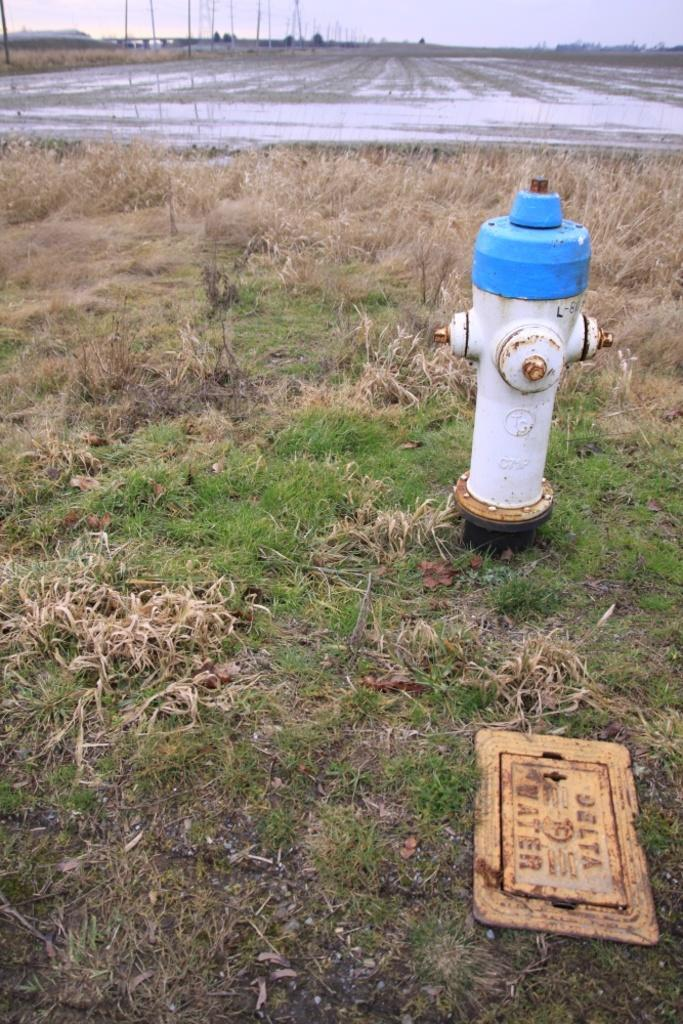What object can be seen in the picture that is used for firefighting purposes? There is a fire hydrant in the picture. What type of vegetation is visible in the picture? There is grass visible in the picture. What is written on the board in the picture? The content of the writing on the board is not mentioned in the facts, so we cannot answer that question. What architectural features can be seen in the background of the picture? There are poles in the background of the picture. What part of the natural environment is visible in the picture? The sky is visible in the background of the picture. What type of shame is being expressed by the fire hydrant in the image? There is no indication of shame or any emotion in the image, as the fire hydrant is an inanimate object. 